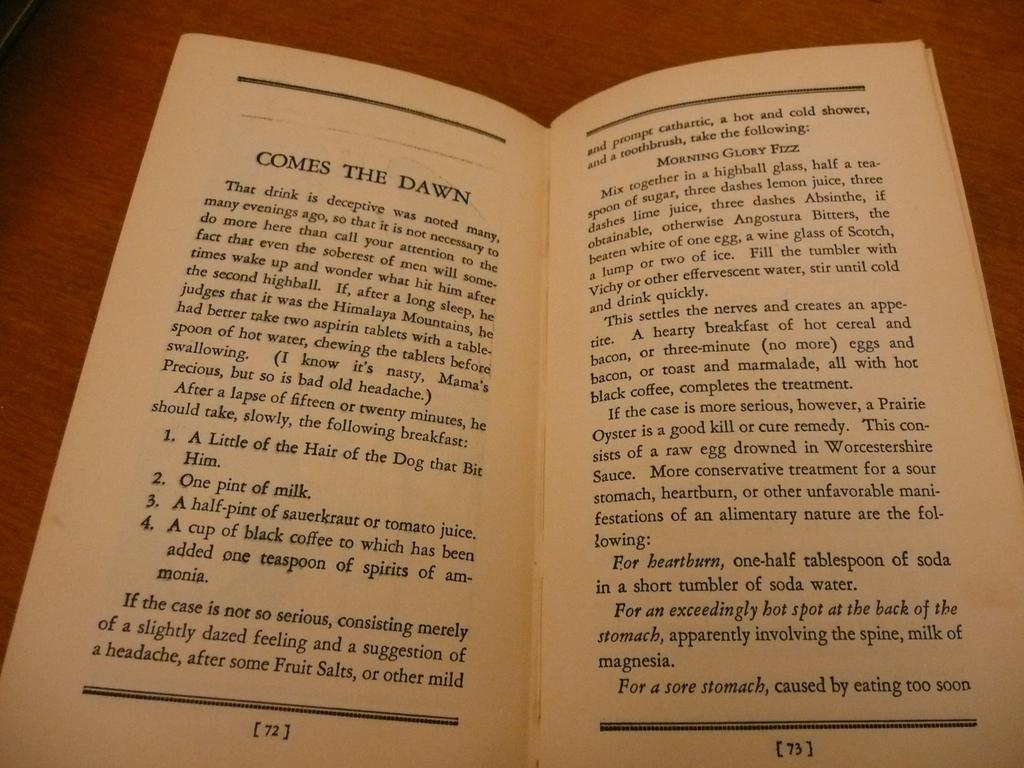<image>
Provide a brief description of the given image. a book where one page is titled 'comes the dawn 